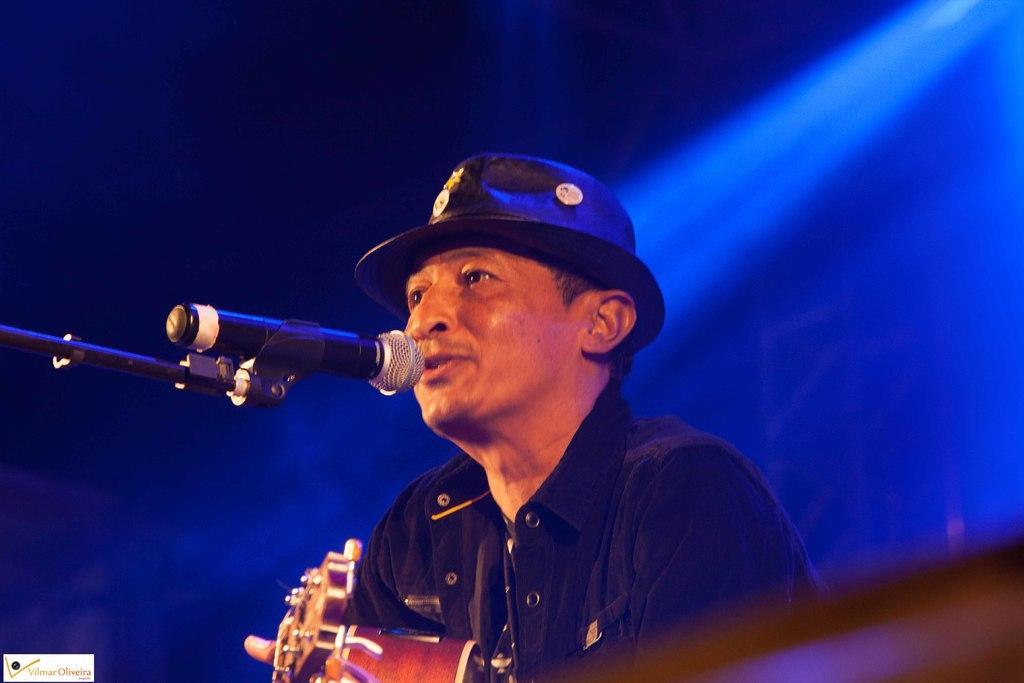How would you summarize this image in a sentence or two? In the middle of this image, there is a person in a jacket, wearing a cap, holding a guitar and singing in front of a mic which is attached to a stand. On the bottom right, there is a watermark. In the background, there is a light. And the background is violet in color. 